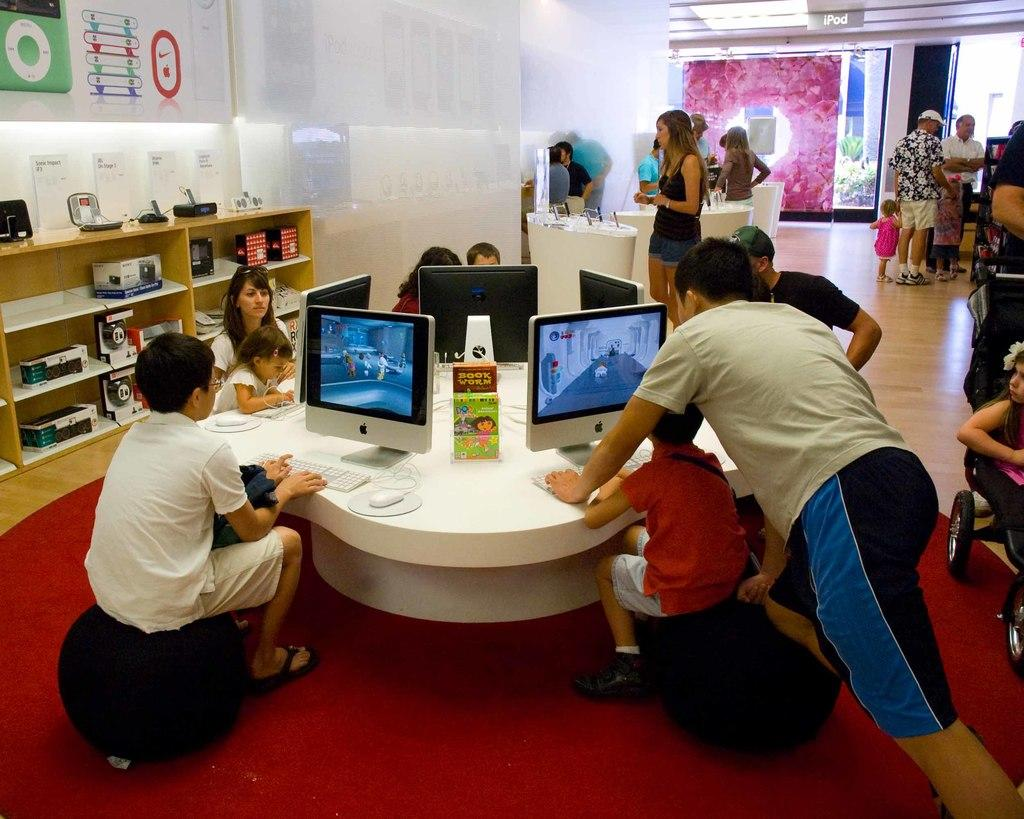How many kids are present in the image? There are many kids in the image. What are the people sitting on in the image? There are people sitting on chairs in the image. What type of table is in the image? There is a round table in the image. What is on the round table? There are many computer systems on the round table. What can be seen in the background of the image? There are many people standing in the background of the image. What type of nut is being used as a guide for the computer systems in the image? There is no nut present in the image, nor is there any indication that a nut is being used as a guide for the computer systems. 